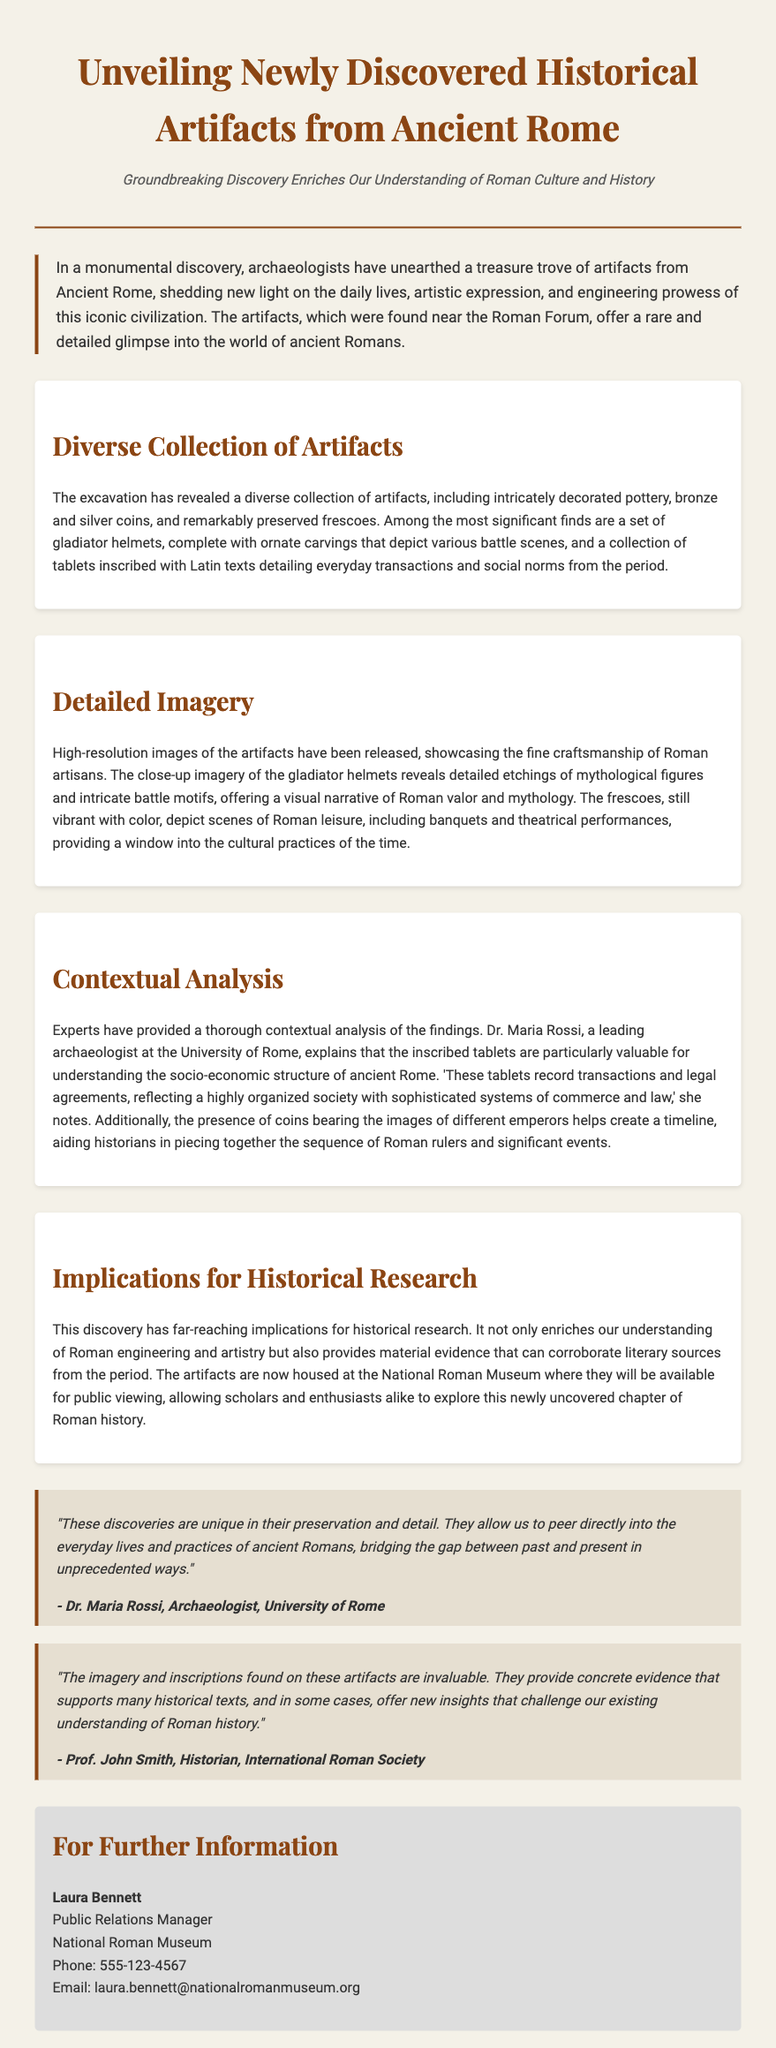What is the location of the artifact discovery? The artifacts were found near the Roman Forum, which is a central area in Ancient Rome.
Answer: Roman Forum Who is the lead archaeologist mentioned in the document? Dr. Maria Rossi is identified as the leading archaeologist at the University of Rome.
Answer: Dr. Maria Rossi What type of items were included in the diverse collection of artifacts? The document lists intricately decorated pottery, bronze and silver coins, and remarkably preserved frescoes among the artifacts.
Answer: pottery, coins, frescoes What is one significant artifact mentioned in the document? A set of gladiator helmets with ornate carvings depicting various battle scenes is highlighted as significant.
Answer: gladiator helmets What do the tablets inscribed with Latin texts detail? The tablets provide details about everyday transactions and social norms from the period of Ancient Rome.
Answer: transactions and social norms What institution is housing the newly discovered artifacts? The artifacts are housed at the National Roman Museum for public viewing and research purposes.
Answer: National Roman Museum How do the coins contribute to historical understanding according to the press release? The presence of coins helps create a timeline of Roman rulers and significant events in history.
Answer: timeline What does Dr. Maria Rossi say about the preservation of the discoveries? She notes that the discoveries are unique in their preservation and detail, allowing for a direct glimpse into ancient Roman life.
Answer: unique in their preservation What color are the frescoes described in the document? The frescoes are described as still vibrant with color, indicating their well-preserved state.
Answer: vibrant with color 